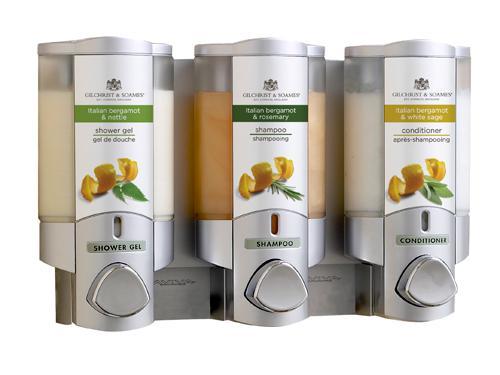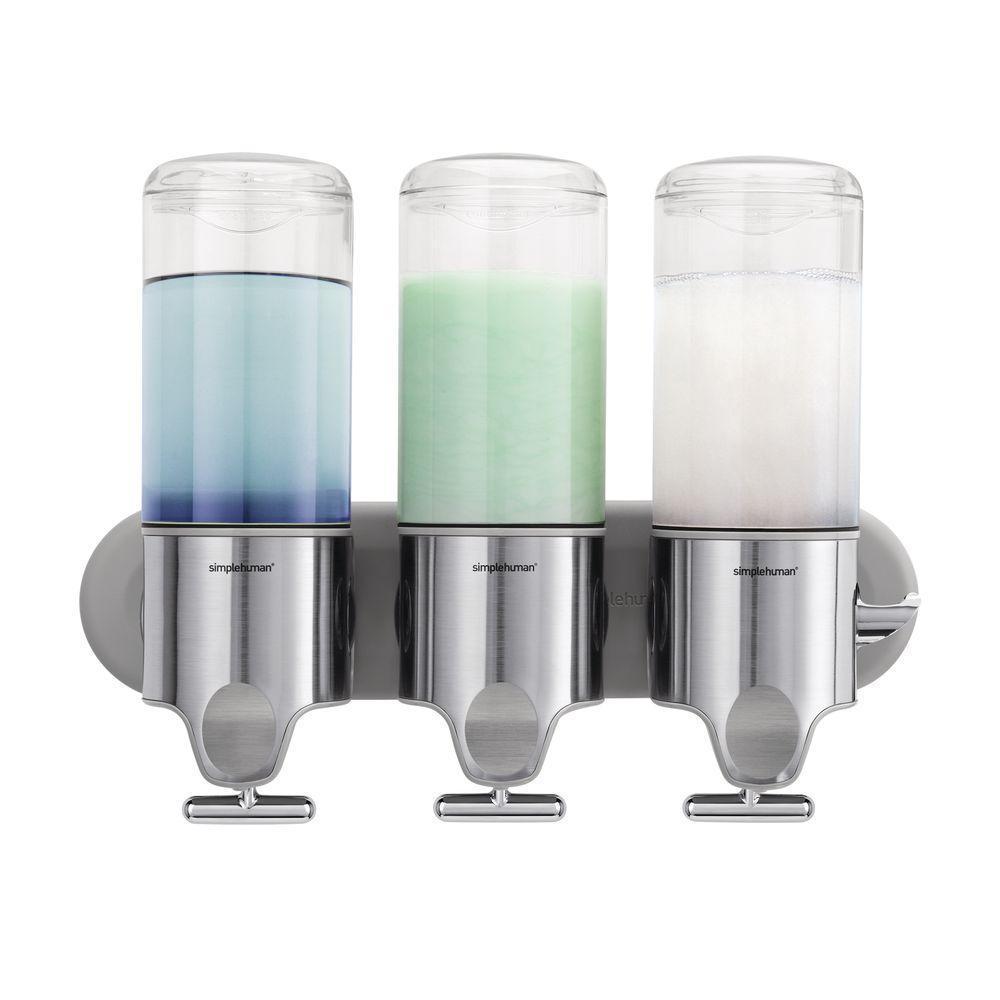The first image is the image on the left, the second image is the image on the right. For the images shown, is this caption "Each image shows a bank of three lotion dispensers, but only one set has the contents written on each dispenser." true? Answer yes or no. Yes. The first image is the image on the left, the second image is the image on the right. Evaluate the accuracy of this statement regarding the images: "The left and right image contains the same number of wall soap dispensers.". Is it true? Answer yes or no. Yes. 